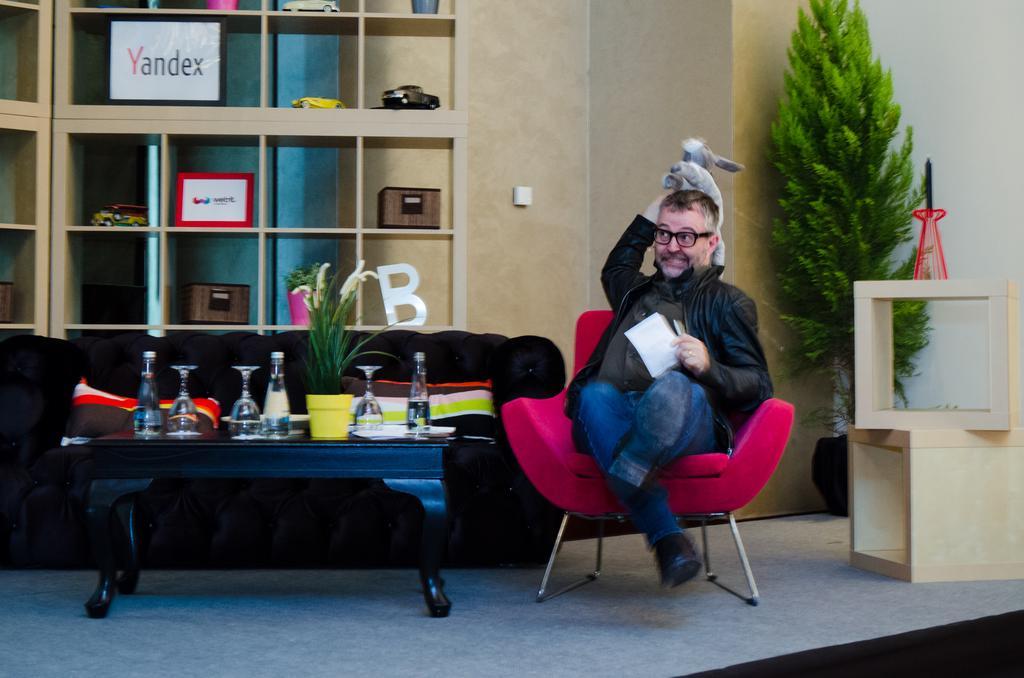In one or two sentences, can you explain what this image depicts? In this image i can see a couch and a chair, the man is setting on the chair wearing a shoe, the man is holding a toy and performing some action. Beside a chair there is a table ,on the table there are three glasses and three bottles,a small pot,back of the couch there is a shelf on shelf there are three toy car, two blocks, and two banners. Beside a chair there is small plant ,in front of the plant there are two wooden blocks. 